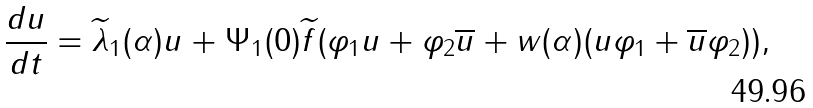Convert formula to latex. <formula><loc_0><loc_0><loc_500><loc_500>\frac { d u } { d t } = \widetilde { \lambda } _ { 1 } ( \alpha ) u + \Psi _ { 1 } ( 0 ) \widetilde { f } ( \varphi _ { 1 } u + \varphi _ { 2 } \overline { u } + w ( \alpha ) ( u \varphi _ { 1 } + \overline { u } \varphi _ { 2 } ) ) ,</formula> 